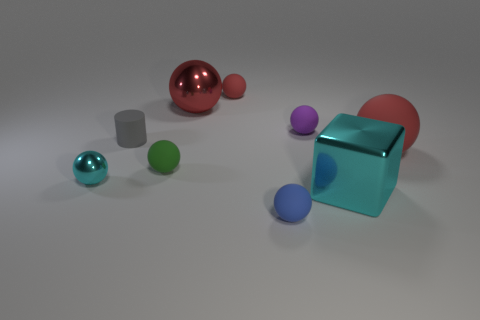Subtract all red spheres. How many were subtracted if there are1red spheres left? 2 Subtract all green spheres. How many spheres are left? 6 Subtract all blue cylinders. How many red balls are left? 3 Subtract all big red metal balls. How many balls are left? 6 Subtract 1 spheres. How many spheres are left? 6 Add 1 large purple rubber cylinders. How many objects exist? 10 Subtract all red spheres. Subtract all blue cylinders. How many spheres are left? 4 Subtract all cubes. How many objects are left? 8 Add 8 red rubber balls. How many red rubber balls exist? 10 Subtract 0 gray cubes. How many objects are left? 9 